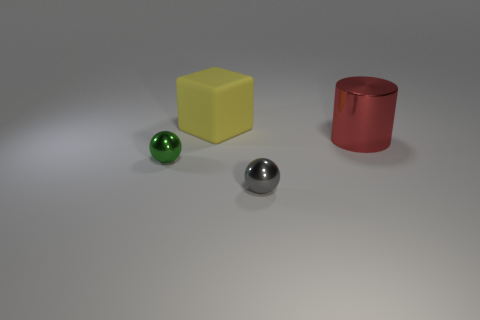Do the cylinder and the rubber object have the same color?
Your answer should be compact. No. How many tiny spheres are the same color as the large block?
Your answer should be compact. 0. What shape is the shiny object that is behind the green thing?
Ensure brevity in your answer.  Cylinder. There is a small sphere that is right of the big matte object; are there any metallic things left of it?
Offer a very short reply. Yes. How many green objects are made of the same material as the yellow thing?
Your answer should be compact. 0. What size is the object behind the large thing that is in front of the big object that is behind the red metallic object?
Your answer should be very brief. Large. How many yellow matte blocks are left of the yellow block?
Make the answer very short. 0. Is the number of big rubber things greater than the number of tiny blue matte balls?
Your answer should be very brief. Yes. How big is the metallic thing that is behind the gray shiny thing and on the left side of the red metal cylinder?
Give a very brief answer. Small. There is a thing that is to the right of the small shiny object in front of the tiny ball that is behind the gray metal ball; what is it made of?
Provide a short and direct response. Metal. 